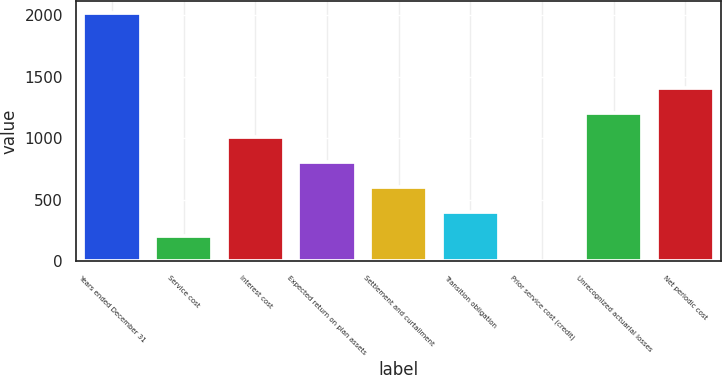Convert chart to OTSL. <chart><loc_0><loc_0><loc_500><loc_500><bar_chart><fcel>Years ended December 31<fcel>Service cost<fcel>Interest cost<fcel>Expected return on plan assets<fcel>Settlement and curtailment<fcel>Transition obligation<fcel>Prior service cost (credit)<fcel>Unrecognized actuarial losses<fcel>Net periodic cost<nl><fcel>2012<fcel>201.29<fcel>1006.05<fcel>804.86<fcel>603.67<fcel>402.48<fcel>0.1<fcel>1207.24<fcel>1408.43<nl></chart> 